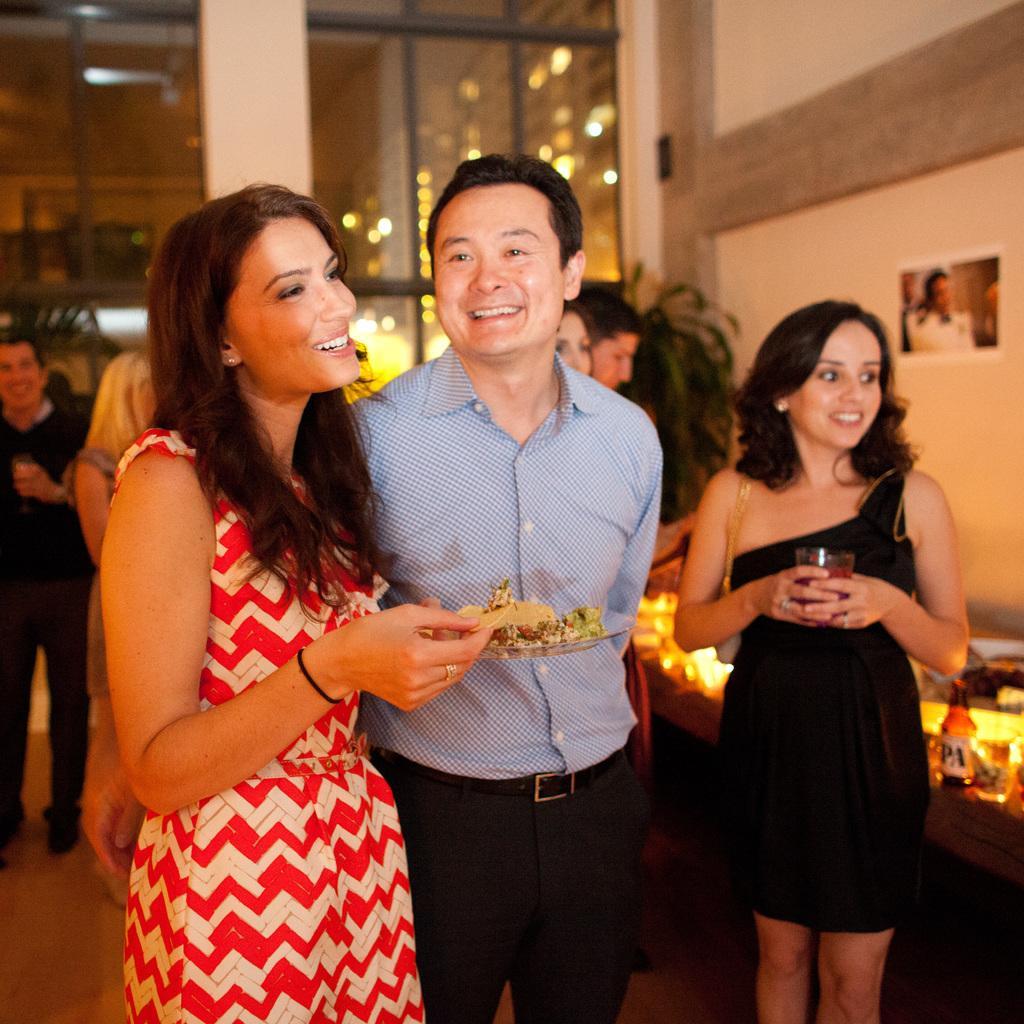How would you summarize this image in a sentence or two? 3 people are standing in a room. The person at the left is holding a plate of food. The person at the right is wearing a black dress and holding a glass of drink in her hand. Behind them there are other people standing. At the right there is a table on which there is a glass bottle and other items. 